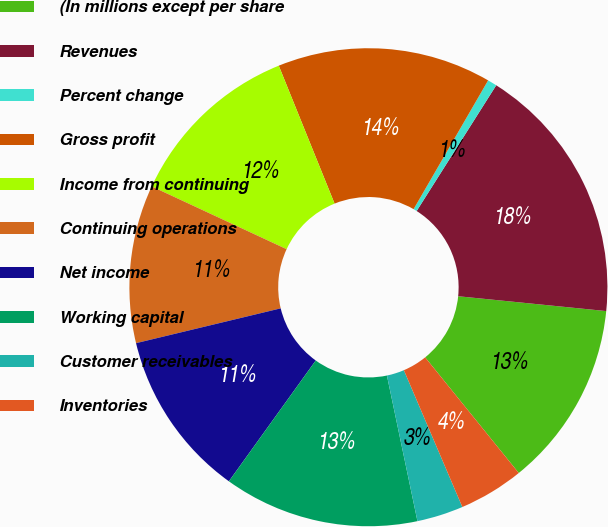Convert chart. <chart><loc_0><loc_0><loc_500><loc_500><pie_chart><fcel>(In millions except per share<fcel>Revenues<fcel>Percent change<fcel>Gross profit<fcel>Income from continuing<fcel>Continuing operations<fcel>Net income<fcel>Working capital<fcel>Customer receivables<fcel>Inventories<nl><fcel>12.58%<fcel>17.61%<fcel>0.63%<fcel>14.47%<fcel>11.95%<fcel>10.69%<fcel>11.32%<fcel>13.21%<fcel>3.14%<fcel>4.4%<nl></chart> 